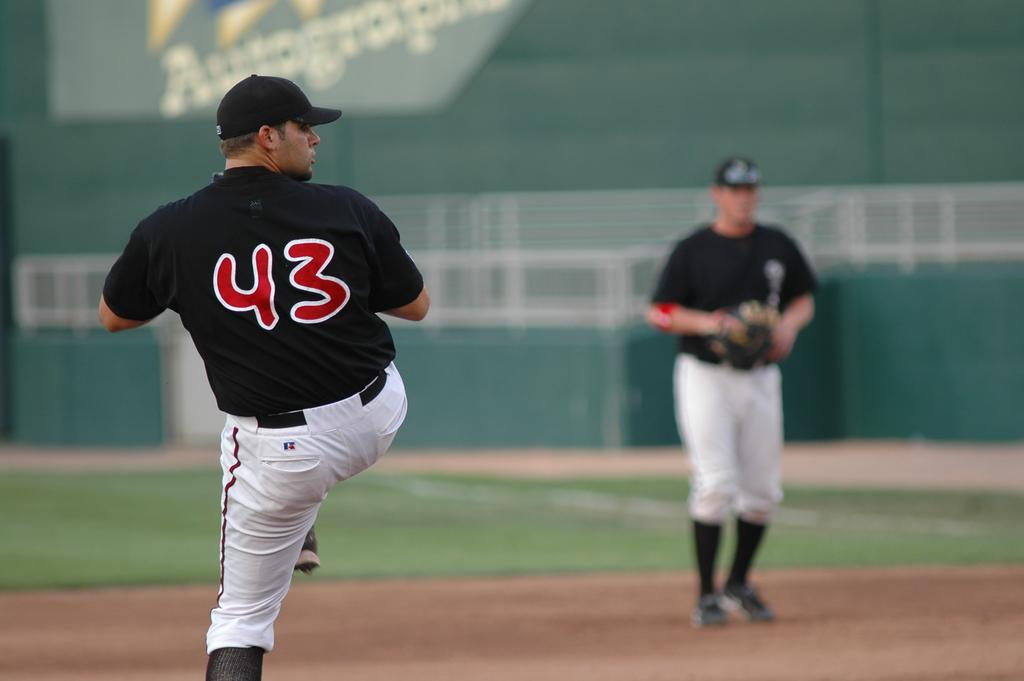<image>
Provide a brief description of the given image. A left handed pitcher getting ready to throw wearing #43 